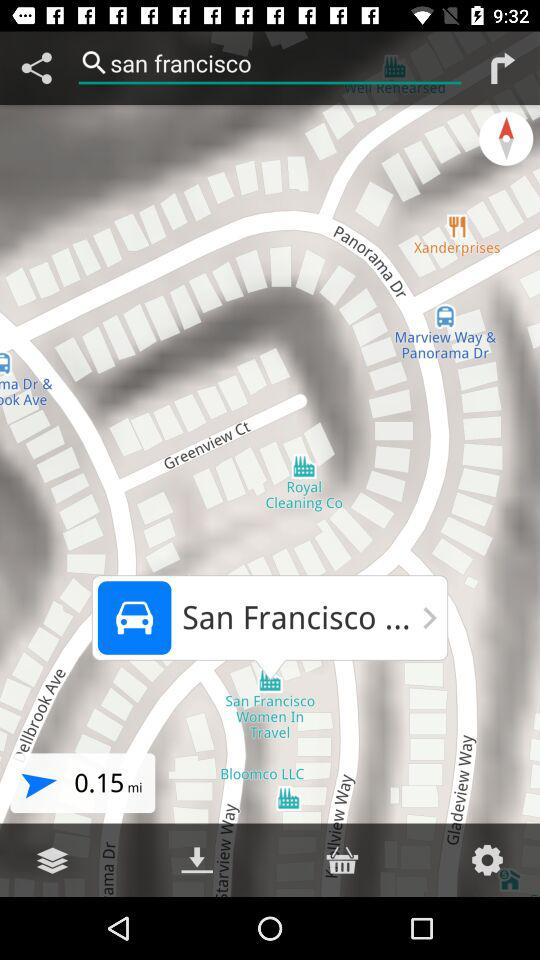What is the given distance? The given distance is 0.15 miles. 